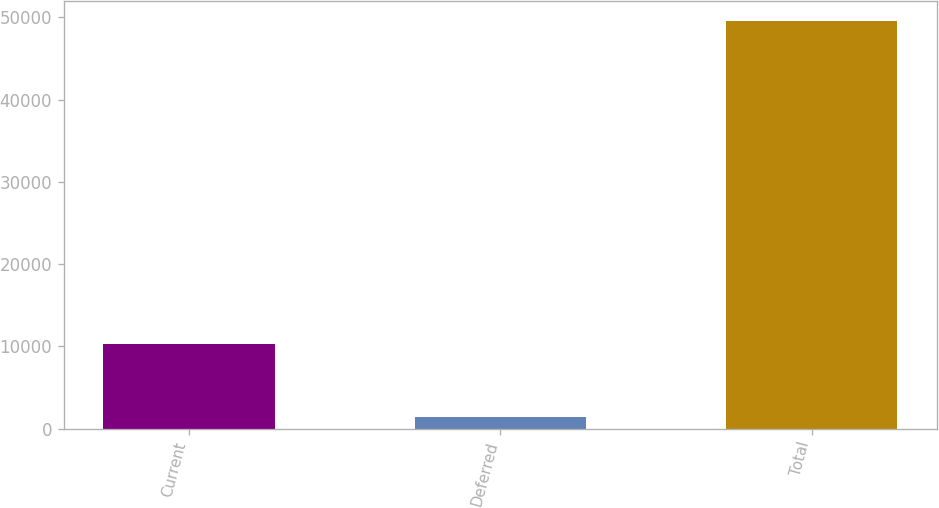<chart> <loc_0><loc_0><loc_500><loc_500><bar_chart><fcel>Current<fcel>Deferred<fcel>Total<nl><fcel>10323<fcel>1362<fcel>49511<nl></chart> 